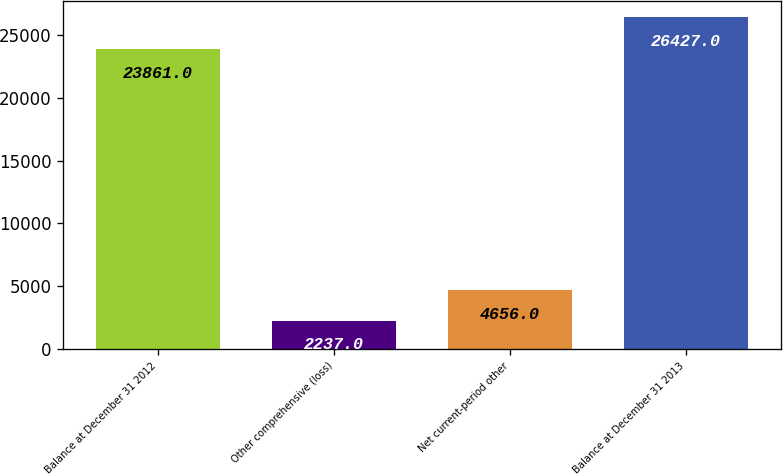Convert chart. <chart><loc_0><loc_0><loc_500><loc_500><bar_chart><fcel>Balance at December 31 2012<fcel>Other comprehensive (loss)<fcel>Net current-period other<fcel>Balance at December 31 2013<nl><fcel>23861<fcel>2237<fcel>4656<fcel>26427<nl></chart> 